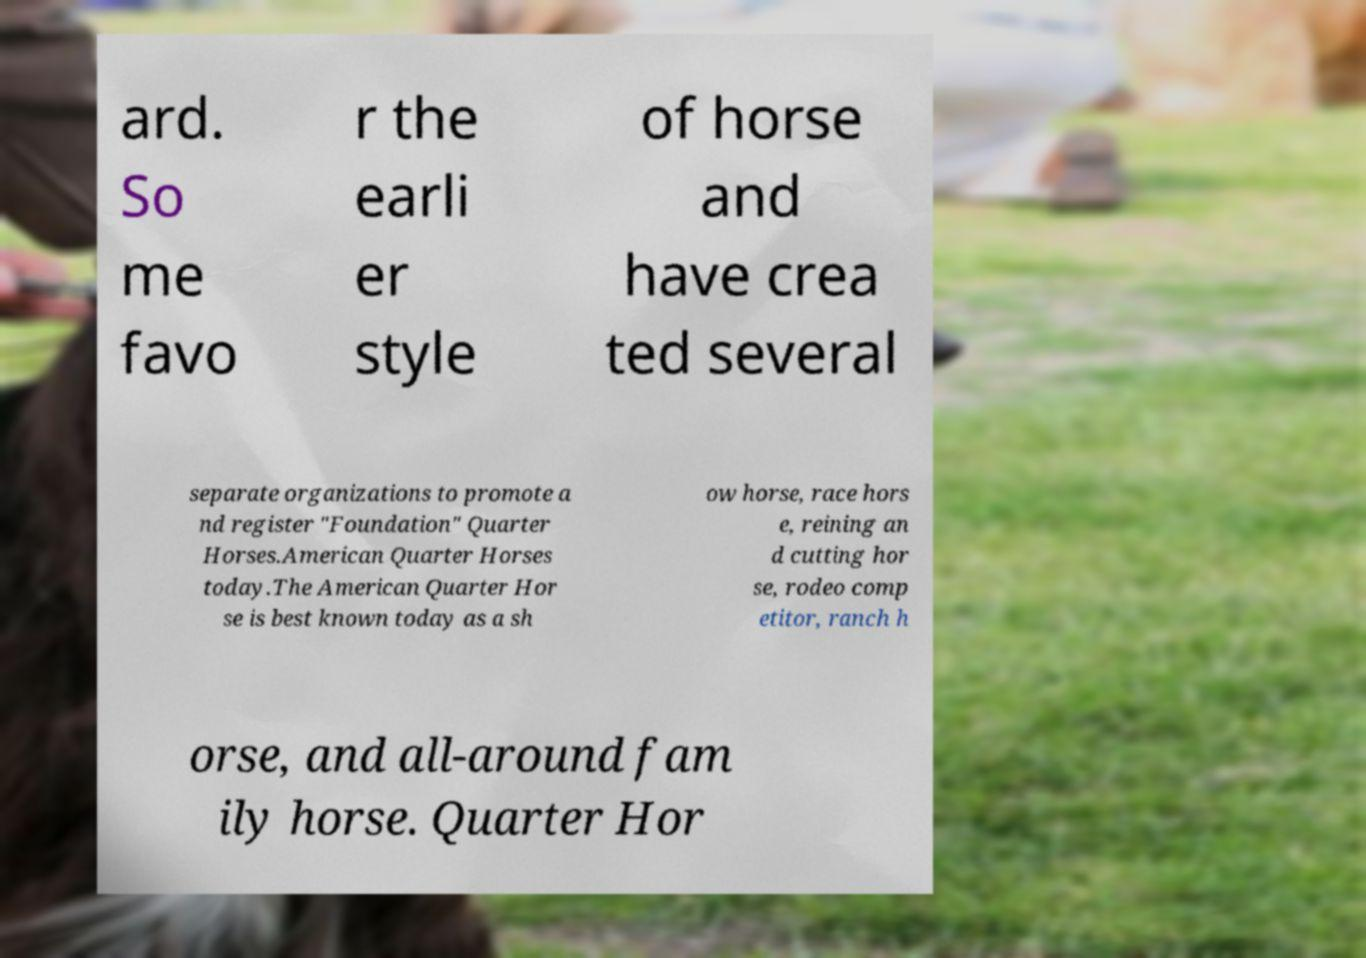Can you accurately transcribe the text from the provided image for me? ard. So me favo r the earli er style of horse and have crea ted several separate organizations to promote a nd register "Foundation" Quarter Horses.American Quarter Horses today.The American Quarter Hor se is best known today as a sh ow horse, race hors e, reining an d cutting hor se, rodeo comp etitor, ranch h orse, and all-around fam ily horse. Quarter Hor 